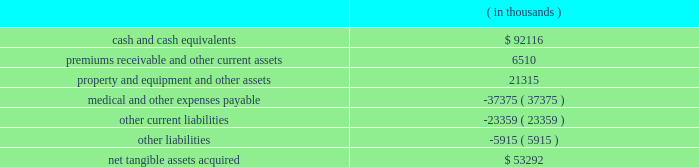Humana inc .
Notes to consolidated financial statements 2014 ( continued ) the grant-date fair value of the award will be estimated using option-pricing models .
In addition , certain tax effects of stock option exercises will be reported as a financing activity rather than an operating activity in the statements of cash flows .
We adopted sfas 123r on january 1 , 2006 under the retrospective transition method using the black-scholes pricing model .
The effect of expensing stock options under a fair value approach using the black-scholes pricing model on diluted earnings per common share for the years ended december 31 , 2005 , 2004 and 2003 is disclosed on page 69 .
In addition , the classification of cash inflows from any excess tax benefit associated with exercising stock options will change from an operating activity to a financing activity in the consolidated statements of cash flows with no impact on total cash flows .
We estimate the impact of this change in classification will decrease operating cash flows ( and increase financing cash flows ) by approximately $ 15.5 million in 2005 , $ 3.7 million in 2004 , and $ 15.2 million in 2003 .
Stock option expense after adopting sfas 123r is not expected to be materially different than our pro forma disclosure on page 69 and is dependent on levels of stock options granted during 2006 .
Acquisitions in january 2006 , our commercial segment reached an agreement to acquire cha service company , or cha health , a health plan serving employer groups in kentucky , for cash consideration of approximately $ 60.0 million plus any excess statutory surplus .
This transaction , which is subject to regulatory approval , is expected to close effective in the second quarter of 2006 .
On december 20 , 2005 , our commercial segment acquired corphealth , inc. , or corphealth , a behavioral health care management company , for cash consideration of approximately $ 54.2 million , including transaction costs .
This acquisition allows humana to integrate coverage of medical and behavior health benefits .
Net tangible assets acquired of $ 6.0 million primarily consisted of cash and cash equivalents .
The purchase price exceeded the estimated fair value of the net tangible assets acquired by approximately $ 48.2 million .
We preliminarily allocated this excess purchase price to other intangible assets of $ 8.6 million and associated deferred tax liabilities of $ 3.2 million , and non-deductible goodwill of $ 42.8 million .
The other intangible assets , which consist primarily of customer contracts , have a weighted average useful life of 14.7 years .
The allocation is subject to change pending completion of the valuation by a third party valuation specialist firm assisting us in evaluating the fair value of the assets acquired .
On february 16 , 2005 , our government segment acquired careplus health plans of florida , or careplus , as well as its affiliated 10 medical centers and pharmacy company .
Careplus provides medicare advantage hmo plans and benefits to medicare advantage members in miami-dade , broward and palm beach counties .
This acquisition enhances our medicare market position in south florida .
We paid approximately $ 444.9 million in cash , including transaction costs .
We financed the transaction with $ 294.0 million of borrowings under our credit agreement and $ 150.9 million of cash on hand .
The purchase price is subject to a balance sheet settlement process with a nine month claims run-out period .
This settlement , which will be reflected as an adjustment to goodwill , is not expected to be material .
The fair value of the acquired tangible assets ( assumed liabilities ) consisted of the following: .

On december 20 , 2005 what was the percent of the net tangible assets acquired to the purchase price? 
Computations: (6 / 54.2)
Answer: 0.1107. 